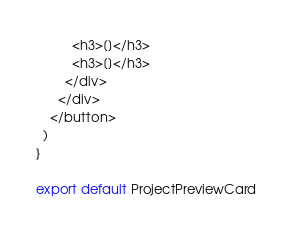Convert code to text. <code><loc_0><loc_0><loc_500><loc_500><_JavaScript_>          <h3>[]</h3>
          <h3>[]</h3>
        </div>
      </div>
    </button>
  )
}

export default ProjectPreviewCard
</code> 